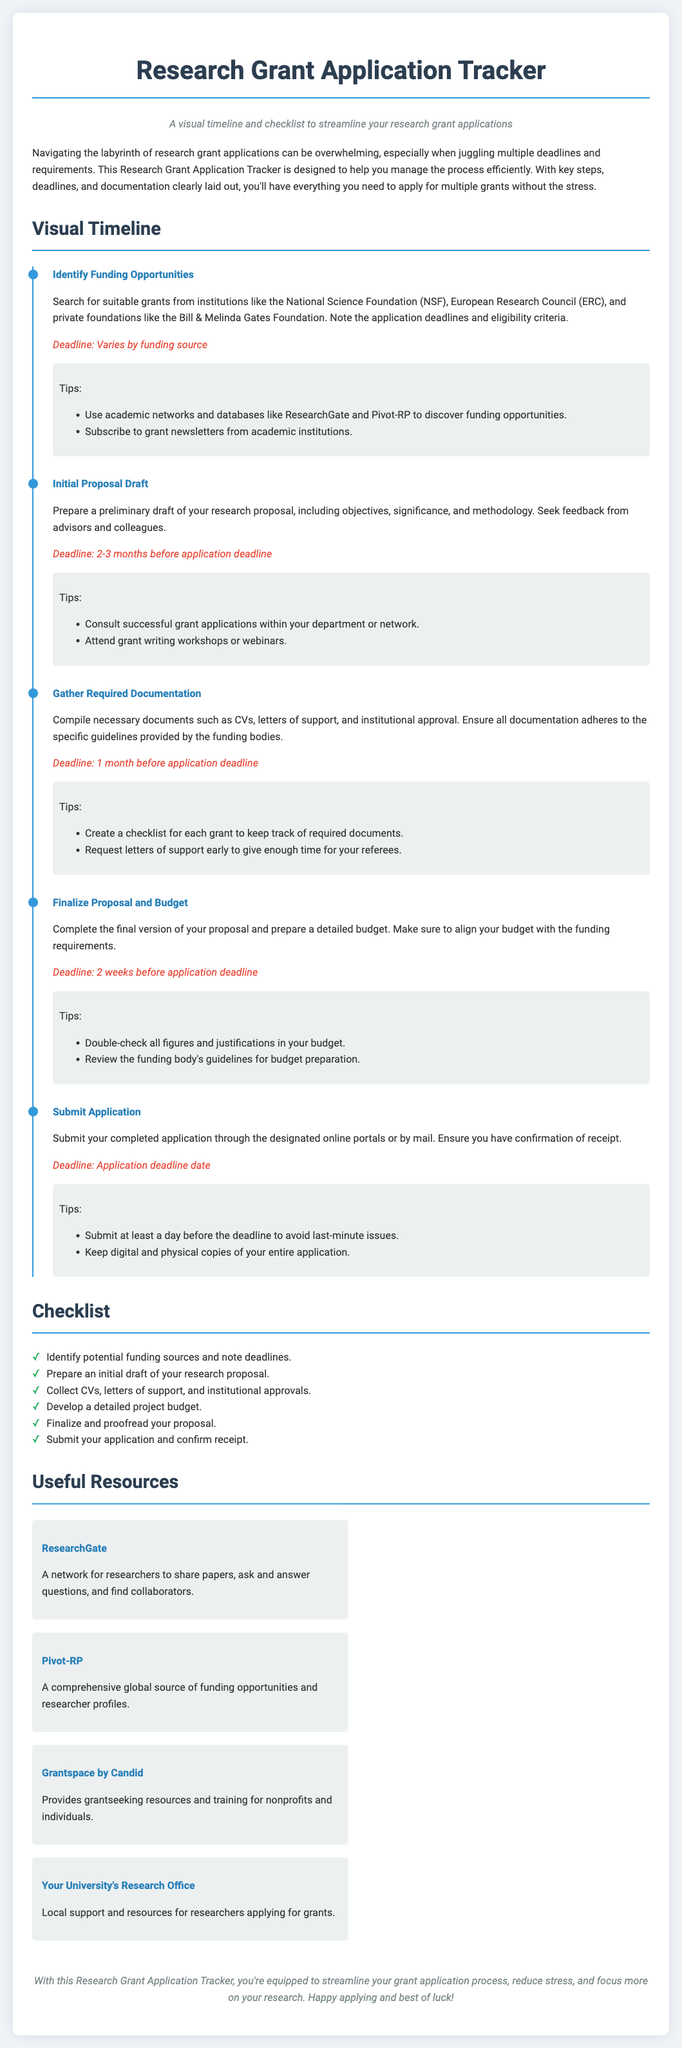What is the title of the document? The title is clearly presented at the top of the document, which is "Research Grant Application Tracker."
Answer: Research Grant Application Tracker What is the deadline for submitting the application? The deadline for submitting the application is specified in the "Submit Application" section.
Answer: Application deadline date How many steps are outlined in the visual timeline? By counting the number of timeline items listed, we find there are five steps.
Answer: 5 What is the suggested action for the "Identify Funding Opportunities" step? The action is indicated in the description of the first timeline item, which involves searching for suitable grants.
Answer: Search for suitable grants Which resource is described as a network for researchers? The resource information indicates ResearchGate as a network for researchers.
Answer: ResearchGate When should the initial proposal draft be prepared? The timeline item notes that the initial proposal draft should be prepared "2-3 months before application deadline."
Answer: 2-3 months before application deadline What color represents tips in the timeline? The background color for tips in the timeline items is light gray, shown in the "timeline-tips" section.
Answer: Light gray What is the purpose of the Research Grant Application Tracker? The purpose is stated in the introduction paragraph of the document, focusing on managing the grant application process efficiently.
Answer: Manage the grant application process efficiently What is included in the checklist? The checklist contains a series of required steps and actions to follow for grant applications.
Answer: Required steps and actions for grant applications 